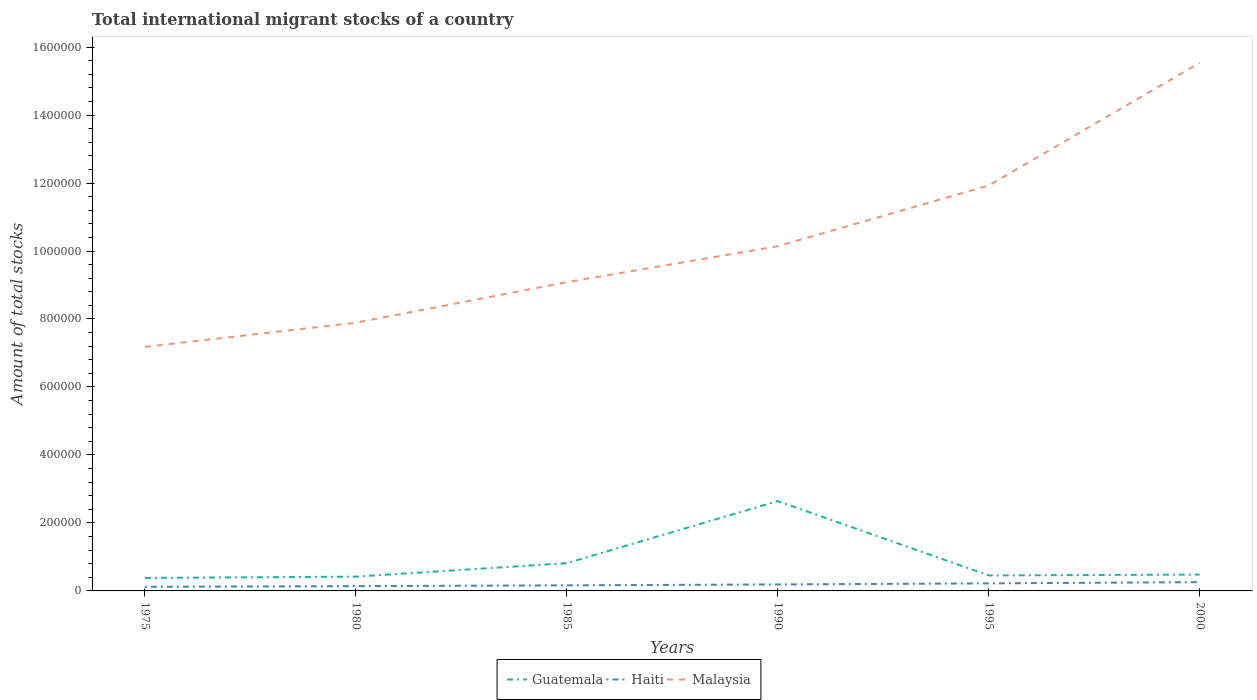Does the line corresponding to Malaysia intersect with the line corresponding to Guatemala?
Offer a very short reply. No. Across all years, what is the maximum amount of total stocks in in Guatemala?
Provide a short and direct response. 3.82e+04. In which year was the amount of total stocks in in Haiti maximum?
Your answer should be very brief. 1975. What is the total amount of total stocks in in Malaysia in the graph?
Give a very brief answer. -4.04e+05. What is the difference between the highest and the second highest amount of total stocks in in Guatemala?
Ensure brevity in your answer.  2.26e+05. How many years are there in the graph?
Make the answer very short. 6. Are the values on the major ticks of Y-axis written in scientific E-notation?
Offer a very short reply. No. Does the graph contain any zero values?
Your answer should be very brief. No. Does the graph contain grids?
Keep it short and to the point. No. Where does the legend appear in the graph?
Keep it short and to the point. Bottom center. What is the title of the graph?
Offer a very short reply. Total international migrant stocks of a country. What is the label or title of the Y-axis?
Provide a short and direct response. Amount of total stocks. What is the Amount of total stocks of Guatemala in 1975?
Provide a succinct answer. 3.82e+04. What is the Amount of total stocks of Haiti in 1975?
Offer a terse response. 1.21e+04. What is the Amount of total stocks of Malaysia in 1975?
Provide a succinct answer. 7.18e+05. What is the Amount of total stocks of Guatemala in 1980?
Offer a terse response. 4.20e+04. What is the Amount of total stocks in Haiti in 1980?
Provide a short and direct response. 1.41e+04. What is the Amount of total stocks in Malaysia in 1980?
Your answer should be compact. 7.89e+05. What is the Amount of total stocks of Guatemala in 1985?
Ensure brevity in your answer.  8.16e+04. What is the Amount of total stocks of Haiti in 1985?
Give a very brief answer. 1.64e+04. What is the Amount of total stocks of Malaysia in 1985?
Your answer should be compact. 9.08e+05. What is the Amount of total stocks of Guatemala in 1990?
Your answer should be compact. 2.64e+05. What is the Amount of total stocks in Haiti in 1990?
Keep it short and to the point. 1.91e+04. What is the Amount of total stocks of Malaysia in 1990?
Make the answer very short. 1.01e+06. What is the Amount of total stocks of Guatemala in 1995?
Keep it short and to the point. 4.55e+04. What is the Amount of total stocks of Haiti in 1995?
Offer a very short reply. 2.22e+04. What is the Amount of total stocks of Malaysia in 1995?
Your answer should be very brief. 1.19e+06. What is the Amount of total stocks of Guatemala in 2000?
Make the answer very short. 4.81e+04. What is the Amount of total stocks in Haiti in 2000?
Your answer should be very brief. 2.58e+04. What is the Amount of total stocks of Malaysia in 2000?
Provide a short and direct response. 1.55e+06. Across all years, what is the maximum Amount of total stocks in Guatemala?
Your response must be concise. 2.64e+05. Across all years, what is the maximum Amount of total stocks of Haiti?
Keep it short and to the point. 2.58e+04. Across all years, what is the maximum Amount of total stocks of Malaysia?
Offer a very short reply. 1.55e+06. Across all years, what is the minimum Amount of total stocks of Guatemala?
Offer a very short reply. 3.82e+04. Across all years, what is the minimum Amount of total stocks of Haiti?
Offer a terse response. 1.21e+04. Across all years, what is the minimum Amount of total stocks in Malaysia?
Make the answer very short. 7.18e+05. What is the total Amount of total stocks in Guatemala in the graph?
Give a very brief answer. 5.20e+05. What is the total Amount of total stocks of Haiti in the graph?
Keep it short and to the point. 1.10e+05. What is the total Amount of total stocks in Malaysia in the graph?
Keep it short and to the point. 6.18e+06. What is the difference between the Amount of total stocks in Guatemala in 1975 and that in 1980?
Offer a terse response. -3820. What is the difference between the Amount of total stocks of Haiti in 1975 and that in 1980?
Keep it short and to the point. -1980. What is the difference between the Amount of total stocks in Malaysia in 1975 and that in 1980?
Ensure brevity in your answer.  -7.12e+04. What is the difference between the Amount of total stocks of Guatemala in 1975 and that in 1985?
Make the answer very short. -4.34e+04. What is the difference between the Amount of total stocks in Haiti in 1975 and that in 1985?
Ensure brevity in your answer.  -4285. What is the difference between the Amount of total stocks of Malaysia in 1975 and that in 1985?
Your response must be concise. -1.90e+05. What is the difference between the Amount of total stocks in Guatemala in 1975 and that in 1990?
Give a very brief answer. -2.26e+05. What is the difference between the Amount of total stocks of Haiti in 1975 and that in 1990?
Your answer should be very brief. -6966. What is the difference between the Amount of total stocks in Malaysia in 1975 and that in 1990?
Offer a very short reply. -2.96e+05. What is the difference between the Amount of total stocks of Guatemala in 1975 and that in 1995?
Ensure brevity in your answer.  -7332. What is the difference between the Amount of total stocks of Haiti in 1975 and that in 1995?
Make the answer very short. -1.01e+04. What is the difference between the Amount of total stocks in Malaysia in 1975 and that in 1995?
Your response must be concise. -4.75e+05. What is the difference between the Amount of total stocks in Guatemala in 1975 and that in 2000?
Keep it short and to the point. -9918. What is the difference between the Amount of total stocks in Haiti in 1975 and that in 2000?
Make the answer very short. -1.37e+04. What is the difference between the Amount of total stocks of Malaysia in 1975 and that in 2000?
Offer a terse response. -8.36e+05. What is the difference between the Amount of total stocks in Guatemala in 1980 and that in 1985?
Your answer should be compact. -3.96e+04. What is the difference between the Amount of total stocks in Haiti in 1980 and that in 1985?
Your answer should be compact. -2305. What is the difference between the Amount of total stocks in Malaysia in 1980 and that in 1985?
Offer a terse response. -1.19e+05. What is the difference between the Amount of total stocks of Guatemala in 1980 and that in 1990?
Give a very brief answer. -2.22e+05. What is the difference between the Amount of total stocks in Haiti in 1980 and that in 1990?
Make the answer very short. -4986. What is the difference between the Amount of total stocks of Malaysia in 1980 and that in 1990?
Keep it short and to the point. -2.25e+05. What is the difference between the Amount of total stocks in Guatemala in 1980 and that in 1995?
Ensure brevity in your answer.  -3512. What is the difference between the Amount of total stocks in Haiti in 1980 and that in 1995?
Keep it short and to the point. -8105. What is the difference between the Amount of total stocks of Malaysia in 1980 and that in 1995?
Give a very brief answer. -4.04e+05. What is the difference between the Amount of total stocks in Guatemala in 1980 and that in 2000?
Your response must be concise. -6098. What is the difference between the Amount of total stocks of Haiti in 1980 and that in 2000?
Your answer should be very brief. -1.17e+04. What is the difference between the Amount of total stocks of Malaysia in 1980 and that in 2000?
Give a very brief answer. -7.65e+05. What is the difference between the Amount of total stocks of Guatemala in 1985 and that in 1990?
Keep it short and to the point. -1.83e+05. What is the difference between the Amount of total stocks in Haiti in 1985 and that in 1990?
Make the answer very short. -2681. What is the difference between the Amount of total stocks of Malaysia in 1985 and that in 1990?
Offer a very short reply. -1.06e+05. What is the difference between the Amount of total stocks in Guatemala in 1985 and that in 1995?
Provide a succinct answer. 3.61e+04. What is the difference between the Amount of total stocks in Haiti in 1985 and that in 1995?
Provide a short and direct response. -5800. What is the difference between the Amount of total stocks in Malaysia in 1985 and that in 1995?
Keep it short and to the point. -2.84e+05. What is the difference between the Amount of total stocks in Guatemala in 1985 and that in 2000?
Your answer should be compact. 3.35e+04. What is the difference between the Amount of total stocks in Haiti in 1985 and that in 2000?
Provide a short and direct response. -9429. What is the difference between the Amount of total stocks in Malaysia in 1985 and that in 2000?
Offer a terse response. -6.45e+05. What is the difference between the Amount of total stocks in Guatemala in 1990 and that in 1995?
Make the answer very short. 2.19e+05. What is the difference between the Amount of total stocks in Haiti in 1990 and that in 1995?
Your answer should be compact. -3119. What is the difference between the Amount of total stocks of Malaysia in 1990 and that in 1995?
Provide a short and direct response. -1.79e+05. What is the difference between the Amount of total stocks in Guatemala in 1990 and that in 2000?
Your response must be concise. 2.16e+05. What is the difference between the Amount of total stocks of Haiti in 1990 and that in 2000?
Provide a succinct answer. -6748. What is the difference between the Amount of total stocks of Malaysia in 1990 and that in 2000?
Provide a short and direct response. -5.40e+05. What is the difference between the Amount of total stocks in Guatemala in 1995 and that in 2000?
Keep it short and to the point. -2586. What is the difference between the Amount of total stocks in Haiti in 1995 and that in 2000?
Your answer should be compact. -3629. What is the difference between the Amount of total stocks in Malaysia in 1995 and that in 2000?
Give a very brief answer. -3.61e+05. What is the difference between the Amount of total stocks in Guatemala in 1975 and the Amount of total stocks in Haiti in 1980?
Your answer should be very brief. 2.41e+04. What is the difference between the Amount of total stocks of Guatemala in 1975 and the Amount of total stocks of Malaysia in 1980?
Offer a very short reply. -7.51e+05. What is the difference between the Amount of total stocks of Haiti in 1975 and the Amount of total stocks of Malaysia in 1980?
Offer a very short reply. -7.77e+05. What is the difference between the Amount of total stocks of Guatemala in 1975 and the Amount of total stocks of Haiti in 1985?
Your answer should be compact. 2.18e+04. What is the difference between the Amount of total stocks of Guatemala in 1975 and the Amount of total stocks of Malaysia in 1985?
Offer a terse response. -8.70e+05. What is the difference between the Amount of total stocks of Haiti in 1975 and the Amount of total stocks of Malaysia in 1985?
Offer a terse response. -8.96e+05. What is the difference between the Amount of total stocks in Guatemala in 1975 and the Amount of total stocks in Haiti in 1990?
Keep it short and to the point. 1.91e+04. What is the difference between the Amount of total stocks in Guatemala in 1975 and the Amount of total stocks in Malaysia in 1990?
Offer a terse response. -9.76e+05. What is the difference between the Amount of total stocks in Haiti in 1975 and the Amount of total stocks in Malaysia in 1990?
Ensure brevity in your answer.  -1.00e+06. What is the difference between the Amount of total stocks in Guatemala in 1975 and the Amount of total stocks in Haiti in 1995?
Ensure brevity in your answer.  1.60e+04. What is the difference between the Amount of total stocks of Guatemala in 1975 and the Amount of total stocks of Malaysia in 1995?
Your answer should be compact. -1.15e+06. What is the difference between the Amount of total stocks of Haiti in 1975 and the Amount of total stocks of Malaysia in 1995?
Ensure brevity in your answer.  -1.18e+06. What is the difference between the Amount of total stocks in Guatemala in 1975 and the Amount of total stocks in Haiti in 2000?
Ensure brevity in your answer.  1.24e+04. What is the difference between the Amount of total stocks in Guatemala in 1975 and the Amount of total stocks in Malaysia in 2000?
Ensure brevity in your answer.  -1.52e+06. What is the difference between the Amount of total stocks in Haiti in 1975 and the Amount of total stocks in Malaysia in 2000?
Keep it short and to the point. -1.54e+06. What is the difference between the Amount of total stocks in Guatemala in 1980 and the Amount of total stocks in Haiti in 1985?
Provide a short and direct response. 2.56e+04. What is the difference between the Amount of total stocks of Guatemala in 1980 and the Amount of total stocks of Malaysia in 1985?
Your answer should be compact. -8.66e+05. What is the difference between the Amount of total stocks in Haiti in 1980 and the Amount of total stocks in Malaysia in 1985?
Give a very brief answer. -8.94e+05. What is the difference between the Amount of total stocks in Guatemala in 1980 and the Amount of total stocks in Haiti in 1990?
Keep it short and to the point. 2.29e+04. What is the difference between the Amount of total stocks in Guatemala in 1980 and the Amount of total stocks in Malaysia in 1990?
Provide a short and direct response. -9.72e+05. What is the difference between the Amount of total stocks in Haiti in 1980 and the Amount of total stocks in Malaysia in 1990?
Your response must be concise. -1.00e+06. What is the difference between the Amount of total stocks of Guatemala in 1980 and the Amount of total stocks of Haiti in 1995?
Make the answer very short. 1.98e+04. What is the difference between the Amount of total stocks of Guatemala in 1980 and the Amount of total stocks of Malaysia in 1995?
Offer a terse response. -1.15e+06. What is the difference between the Amount of total stocks in Haiti in 1980 and the Amount of total stocks in Malaysia in 1995?
Provide a succinct answer. -1.18e+06. What is the difference between the Amount of total stocks in Guatemala in 1980 and the Amount of total stocks in Haiti in 2000?
Offer a terse response. 1.62e+04. What is the difference between the Amount of total stocks of Guatemala in 1980 and the Amount of total stocks of Malaysia in 2000?
Provide a succinct answer. -1.51e+06. What is the difference between the Amount of total stocks of Haiti in 1980 and the Amount of total stocks of Malaysia in 2000?
Provide a short and direct response. -1.54e+06. What is the difference between the Amount of total stocks in Guatemala in 1985 and the Amount of total stocks in Haiti in 1990?
Offer a very short reply. 6.25e+04. What is the difference between the Amount of total stocks of Guatemala in 1985 and the Amount of total stocks of Malaysia in 1990?
Provide a short and direct response. -9.33e+05. What is the difference between the Amount of total stocks of Haiti in 1985 and the Amount of total stocks of Malaysia in 1990?
Make the answer very short. -9.98e+05. What is the difference between the Amount of total stocks of Guatemala in 1985 and the Amount of total stocks of Haiti in 1995?
Provide a short and direct response. 5.94e+04. What is the difference between the Amount of total stocks of Guatemala in 1985 and the Amount of total stocks of Malaysia in 1995?
Provide a succinct answer. -1.11e+06. What is the difference between the Amount of total stocks in Haiti in 1985 and the Amount of total stocks in Malaysia in 1995?
Offer a very short reply. -1.18e+06. What is the difference between the Amount of total stocks in Guatemala in 1985 and the Amount of total stocks in Haiti in 2000?
Provide a short and direct response. 5.58e+04. What is the difference between the Amount of total stocks in Guatemala in 1985 and the Amount of total stocks in Malaysia in 2000?
Give a very brief answer. -1.47e+06. What is the difference between the Amount of total stocks of Haiti in 1985 and the Amount of total stocks of Malaysia in 2000?
Ensure brevity in your answer.  -1.54e+06. What is the difference between the Amount of total stocks in Guatemala in 1990 and the Amount of total stocks in Haiti in 1995?
Provide a succinct answer. 2.42e+05. What is the difference between the Amount of total stocks of Guatemala in 1990 and the Amount of total stocks of Malaysia in 1995?
Your answer should be compact. -9.28e+05. What is the difference between the Amount of total stocks in Haiti in 1990 and the Amount of total stocks in Malaysia in 1995?
Provide a succinct answer. -1.17e+06. What is the difference between the Amount of total stocks of Guatemala in 1990 and the Amount of total stocks of Haiti in 2000?
Your answer should be very brief. 2.38e+05. What is the difference between the Amount of total stocks of Guatemala in 1990 and the Amount of total stocks of Malaysia in 2000?
Your answer should be compact. -1.29e+06. What is the difference between the Amount of total stocks in Haiti in 1990 and the Amount of total stocks in Malaysia in 2000?
Ensure brevity in your answer.  -1.53e+06. What is the difference between the Amount of total stocks of Guatemala in 1995 and the Amount of total stocks of Haiti in 2000?
Your answer should be very brief. 1.97e+04. What is the difference between the Amount of total stocks of Guatemala in 1995 and the Amount of total stocks of Malaysia in 2000?
Offer a terse response. -1.51e+06. What is the difference between the Amount of total stocks in Haiti in 1995 and the Amount of total stocks in Malaysia in 2000?
Provide a short and direct response. -1.53e+06. What is the average Amount of total stocks of Guatemala per year?
Keep it short and to the point. 8.66e+04. What is the average Amount of total stocks of Haiti per year?
Ensure brevity in your answer.  1.83e+04. What is the average Amount of total stocks in Malaysia per year?
Keep it short and to the point. 1.03e+06. In the year 1975, what is the difference between the Amount of total stocks of Guatemala and Amount of total stocks of Haiti?
Make the answer very short. 2.61e+04. In the year 1975, what is the difference between the Amount of total stocks in Guatemala and Amount of total stocks in Malaysia?
Give a very brief answer. -6.80e+05. In the year 1975, what is the difference between the Amount of total stocks of Haiti and Amount of total stocks of Malaysia?
Your answer should be very brief. -7.06e+05. In the year 1980, what is the difference between the Amount of total stocks in Guatemala and Amount of total stocks in Haiti?
Provide a short and direct response. 2.79e+04. In the year 1980, what is the difference between the Amount of total stocks of Guatemala and Amount of total stocks of Malaysia?
Provide a short and direct response. -7.47e+05. In the year 1980, what is the difference between the Amount of total stocks in Haiti and Amount of total stocks in Malaysia?
Keep it short and to the point. -7.75e+05. In the year 1985, what is the difference between the Amount of total stocks in Guatemala and Amount of total stocks in Haiti?
Keep it short and to the point. 6.52e+04. In the year 1985, what is the difference between the Amount of total stocks in Guatemala and Amount of total stocks in Malaysia?
Ensure brevity in your answer.  -8.27e+05. In the year 1985, what is the difference between the Amount of total stocks of Haiti and Amount of total stocks of Malaysia?
Give a very brief answer. -8.92e+05. In the year 1990, what is the difference between the Amount of total stocks in Guatemala and Amount of total stocks in Haiti?
Your answer should be very brief. 2.45e+05. In the year 1990, what is the difference between the Amount of total stocks of Guatemala and Amount of total stocks of Malaysia?
Your answer should be compact. -7.50e+05. In the year 1990, what is the difference between the Amount of total stocks of Haiti and Amount of total stocks of Malaysia?
Keep it short and to the point. -9.95e+05. In the year 1995, what is the difference between the Amount of total stocks of Guatemala and Amount of total stocks of Haiti?
Your answer should be very brief. 2.33e+04. In the year 1995, what is the difference between the Amount of total stocks of Guatemala and Amount of total stocks of Malaysia?
Make the answer very short. -1.15e+06. In the year 1995, what is the difference between the Amount of total stocks of Haiti and Amount of total stocks of Malaysia?
Provide a succinct answer. -1.17e+06. In the year 2000, what is the difference between the Amount of total stocks of Guatemala and Amount of total stocks of Haiti?
Your answer should be very brief. 2.23e+04. In the year 2000, what is the difference between the Amount of total stocks in Guatemala and Amount of total stocks in Malaysia?
Your answer should be very brief. -1.51e+06. In the year 2000, what is the difference between the Amount of total stocks in Haiti and Amount of total stocks in Malaysia?
Offer a terse response. -1.53e+06. What is the ratio of the Amount of total stocks in Haiti in 1975 to that in 1980?
Offer a terse response. 0.86. What is the ratio of the Amount of total stocks of Malaysia in 1975 to that in 1980?
Ensure brevity in your answer.  0.91. What is the ratio of the Amount of total stocks of Guatemala in 1975 to that in 1985?
Offer a very short reply. 0.47. What is the ratio of the Amount of total stocks of Haiti in 1975 to that in 1985?
Your response must be concise. 0.74. What is the ratio of the Amount of total stocks in Malaysia in 1975 to that in 1985?
Keep it short and to the point. 0.79. What is the ratio of the Amount of total stocks of Guatemala in 1975 to that in 1990?
Your response must be concise. 0.14. What is the ratio of the Amount of total stocks in Haiti in 1975 to that in 1990?
Give a very brief answer. 0.64. What is the ratio of the Amount of total stocks in Malaysia in 1975 to that in 1990?
Give a very brief answer. 0.71. What is the ratio of the Amount of total stocks in Guatemala in 1975 to that in 1995?
Make the answer very short. 0.84. What is the ratio of the Amount of total stocks in Haiti in 1975 to that in 1995?
Provide a short and direct response. 0.55. What is the ratio of the Amount of total stocks in Malaysia in 1975 to that in 1995?
Your answer should be very brief. 0.6. What is the ratio of the Amount of total stocks in Guatemala in 1975 to that in 2000?
Keep it short and to the point. 0.79. What is the ratio of the Amount of total stocks of Haiti in 1975 to that in 2000?
Provide a succinct answer. 0.47. What is the ratio of the Amount of total stocks in Malaysia in 1975 to that in 2000?
Offer a very short reply. 0.46. What is the ratio of the Amount of total stocks in Guatemala in 1980 to that in 1985?
Make the answer very short. 0.52. What is the ratio of the Amount of total stocks in Haiti in 1980 to that in 1985?
Offer a very short reply. 0.86. What is the ratio of the Amount of total stocks of Malaysia in 1980 to that in 1985?
Your answer should be compact. 0.87. What is the ratio of the Amount of total stocks of Guatemala in 1980 to that in 1990?
Your answer should be very brief. 0.16. What is the ratio of the Amount of total stocks of Haiti in 1980 to that in 1990?
Offer a terse response. 0.74. What is the ratio of the Amount of total stocks in Malaysia in 1980 to that in 1990?
Keep it short and to the point. 0.78. What is the ratio of the Amount of total stocks in Guatemala in 1980 to that in 1995?
Give a very brief answer. 0.92. What is the ratio of the Amount of total stocks of Haiti in 1980 to that in 1995?
Give a very brief answer. 0.64. What is the ratio of the Amount of total stocks in Malaysia in 1980 to that in 1995?
Offer a very short reply. 0.66. What is the ratio of the Amount of total stocks in Guatemala in 1980 to that in 2000?
Give a very brief answer. 0.87. What is the ratio of the Amount of total stocks of Haiti in 1980 to that in 2000?
Provide a succinct answer. 0.55. What is the ratio of the Amount of total stocks in Malaysia in 1980 to that in 2000?
Provide a short and direct response. 0.51. What is the ratio of the Amount of total stocks of Guatemala in 1985 to that in 1990?
Provide a short and direct response. 0.31. What is the ratio of the Amount of total stocks in Haiti in 1985 to that in 1990?
Make the answer very short. 0.86. What is the ratio of the Amount of total stocks in Malaysia in 1985 to that in 1990?
Your answer should be very brief. 0.9. What is the ratio of the Amount of total stocks in Guatemala in 1985 to that in 1995?
Ensure brevity in your answer.  1.79. What is the ratio of the Amount of total stocks of Haiti in 1985 to that in 1995?
Give a very brief answer. 0.74. What is the ratio of the Amount of total stocks in Malaysia in 1985 to that in 1995?
Keep it short and to the point. 0.76. What is the ratio of the Amount of total stocks of Guatemala in 1985 to that in 2000?
Your answer should be very brief. 1.7. What is the ratio of the Amount of total stocks in Haiti in 1985 to that in 2000?
Ensure brevity in your answer.  0.64. What is the ratio of the Amount of total stocks of Malaysia in 1985 to that in 2000?
Offer a very short reply. 0.58. What is the ratio of the Amount of total stocks in Guatemala in 1990 to that in 1995?
Ensure brevity in your answer.  5.8. What is the ratio of the Amount of total stocks of Haiti in 1990 to that in 1995?
Make the answer very short. 0.86. What is the ratio of the Amount of total stocks in Malaysia in 1990 to that in 1995?
Offer a very short reply. 0.85. What is the ratio of the Amount of total stocks in Guatemala in 1990 to that in 2000?
Offer a very short reply. 5.49. What is the ratio of the Amount of total stocks in Haiti in 1990 to that in 2000?
Offer a very short reply. 0.74. What is the ratio of the Amount of total stocks in Malaysia in 1990 to that in 2000?
Offer a very short reply. 0.65. What is the ratio of the Amount of total stocks of Guatemala in 1995 to that in 2000?
Give a very brief answer. 0.95. What is the ratio of the Amount of total stocks of Haiti in 1995 to that in 2000?
Your answer should be very brief. 0.86. What is the ratio of the Amount of total stocks in Malaysia in 1995 to that in 2000?
Provide a short and direct response. 0.77. What is the difference between the highest and the second highest Amount of total stocks in Guatemala?
Your answer should be very brief. 1.83e+05. What is the difference between the highest and the second highest Amount of total stocks in Haiti?
Your response must be concise. 3629. What is the difference between the highest and the second highest Amount of total stocks of Malaysia?
Provide a short and direct response. 3.61e+05. What is the difference between the highest and the lowest Amount of total stocks in Guatemala?
Make the answer very short. 2.26e+05. What is the difference between the highest and the lowest Amount of total stocks of Haiti?
Keep it short and to the point. 1.37e+04. What is the difference between the highest and the lowest Amount of total stocks in Malaysia?
Ensure brevity in your answer.  8.36e+05. 